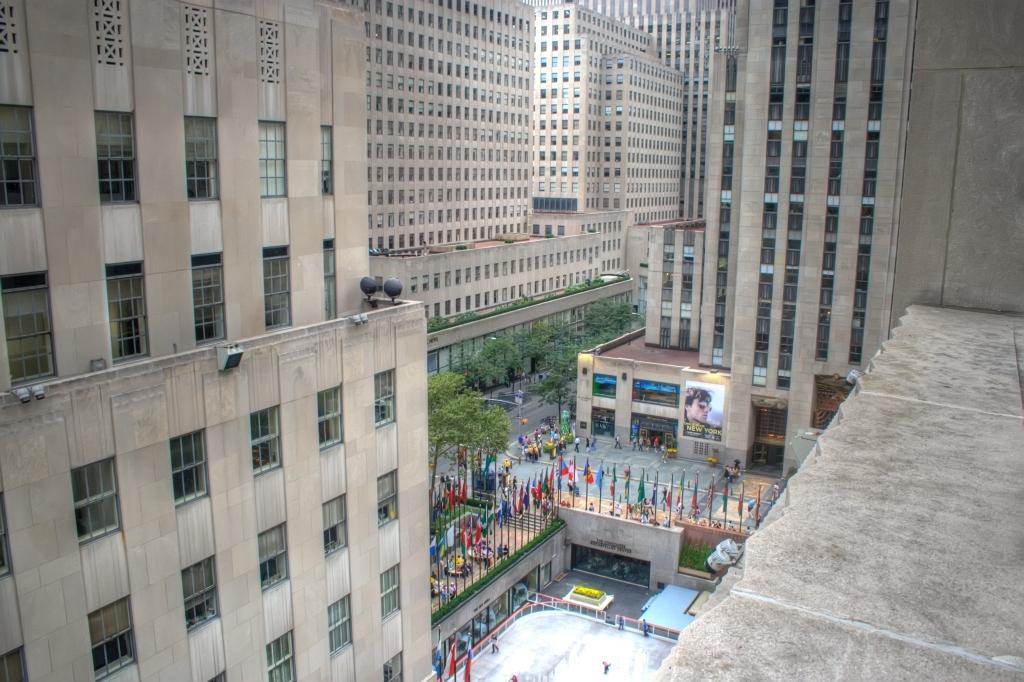How would you summarize this image in a sentence or two? In this image we can see some buildings and there are some flags in the middle and we can see some people and trees. 